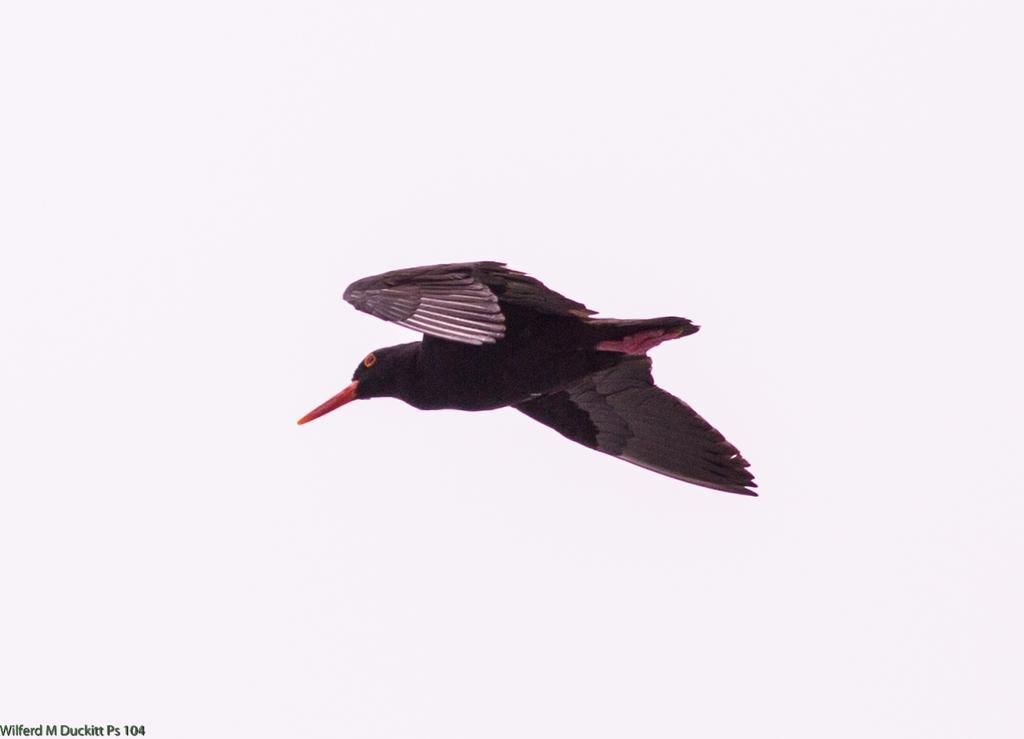Can you describe this image briefly? In this picture I can see a bird flying, there is white background and there is a watermark on the image. 